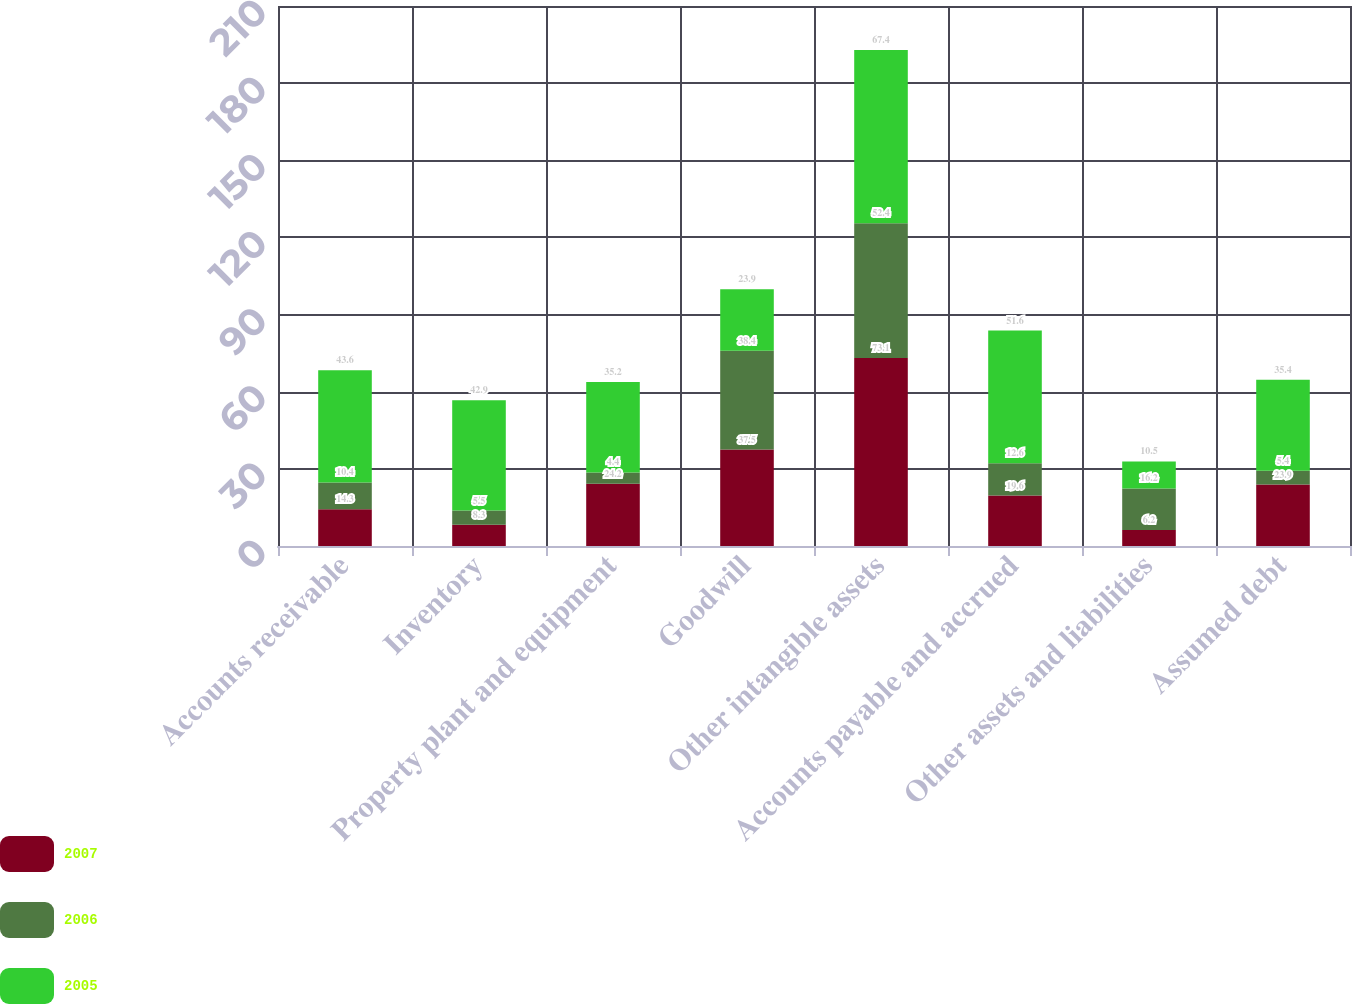Convert chart. <chart><loc_0><loc_0><loc_500><loc_500><stacked_bar_chart><ecel><fcel>Accounts receivable<fcel>Inventory<fcel>Property plant and equipment<fcel>Goodwill<fcel>Other intangible assets<fcel>Accounts payable and accrued<fcel>Other assets and liabilities<fcel>Assumed debt<nl><fcel>2007<fcel>14.3<fcel>8.3<fcel>24.2<fcel>37.5<fcel>73.1<fcel>19.6<fcel>6.2<fcel>23.9<nl><fcel>2006<fcel>10.4<fcel>5.5<fcel>4.4<fcel>38.4<fcel>52.4<fcel>12.6<fcel>16.2<fcel>5.4<nl><fcel>2005<fcel>43.6<fcel>42.9<fcel>35.2<fcel>23.9<fcel>67.4<fcel>51.6<fcel>10.5<fcel>35.4<nl></chart> 